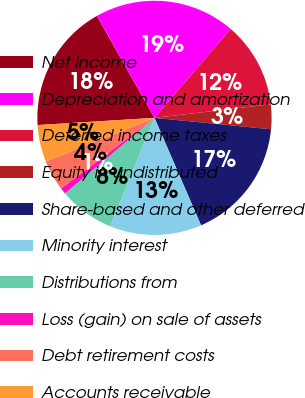Convert chart. <chart><loc_0><loc_0><loc_500><loc_500><pie_chart><fcel>Net income<fcel>Depreciation and amortization<fcel>Deferred income taxes<fcel>Equity in undistributed<fcel>Share-based and other deferred<fcel>Minority interest<fcel>Distributions from<fcel>Loss (gain) on sale of assets<fcel>Debt retirement costs<fcel>Accounts receivable<nl><fcel>17.79%<fcel>19.48%<fcel>11.86%<fcel>3.4%<fcel>16.94%<fcel>12.71%<fcel>7.63%<fcel>0.86%<fcel>4.24%<fcel>5.09%<nl></chart> 